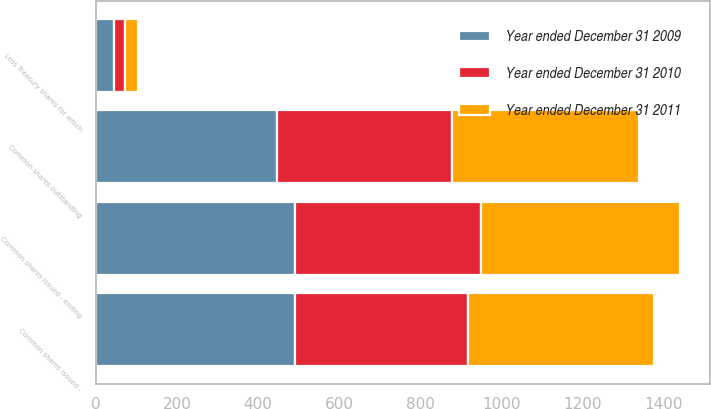Convert chart to OTSL. <chart><loc_0><loc_0><loc_500><loc_500><stacked_bar_chart><ecel><fcel>Common shares issued -<fcel>Common shares issued - ending<fcel>Less Treasury shares for which<fcel>Common shares outstanding<nl><fcel>Year ended December 31 2009<fcel>490.4<fcel>490.4<fcel>44.4<fcel>446<nl><fcel>Year ended December 31 2011<fcel>459.5<fcel>490.4<fcel>30.3<fcel>460.1<nl><fcel>Year ended December 31 2010<fcel>426.6<fcel>459.5<fcel>28.1<fcel>431.4<nl></chart> 